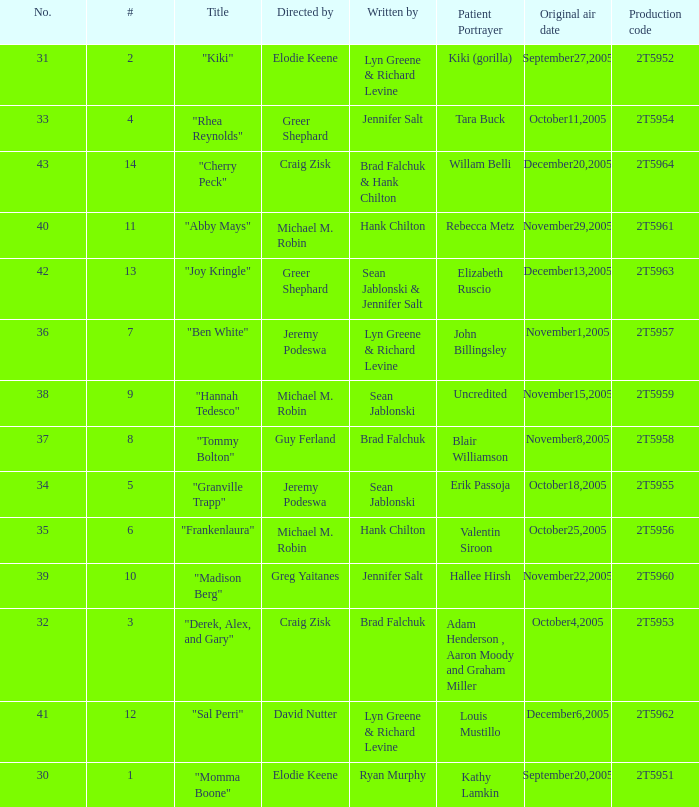Who was the writter for the  episode identified by the production code 2t5954? Jennifer Salt. 